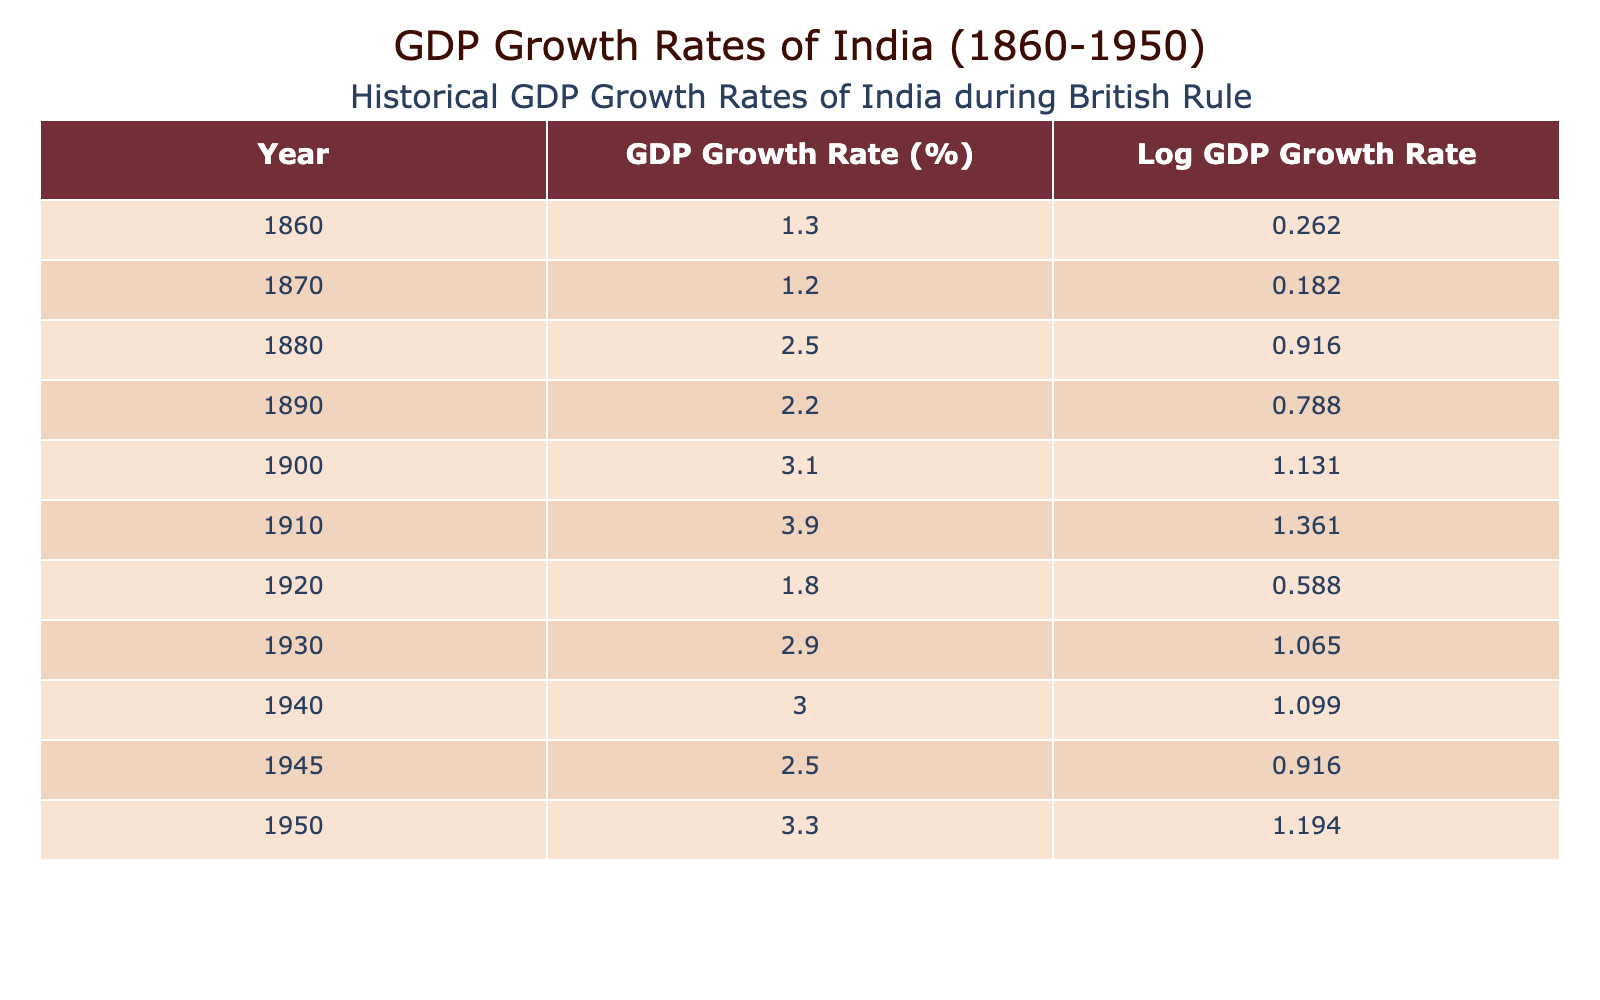What was the GDP growth rate in 1900? Referring to the table, the GDP growth rate for the year 1900 is listed as 3.1%.
Answer: 3.1% In which year did India experience the highest GDP growth rate? By examining the table, the highest GDP growth rate is 3.9%, which occurred in the year 1910.
Answer: 1910 What is the average GDP growth rate from 1860 to 1950? To calculate the average, sum the GDP growth rates from the table: (1.3 + 1.2 + 2.5 + 2.2 + 3.1 + 3.9 + 1.8 + 2.9 + 3.0 + 2.5 + 3.3) = 23.1. There are 11 data points, so the average is 23.1/11 = approximately 2.1%.
Answer: 2.1% Was the GDP growth rate higher in the 1940s than in the 1930s? The GDP growth rate for the 1930s is 2.9% (1930) and 3.0% (1940) while in 1945 it is 2.5%. The average for the 1940s is (3.0 + 2.5)/2 = 2.75%, which is lower than the average for the 1930s (2.9%). Thus, it is false.
Answer: No What is the difference in GDP growth rate between years 1880 and 1945? The GDP growth rate in 1880 is 2.5% and in 1945 it is 2.5%. Therefore, the difference is 2.5% - 2.5% = 0%.
Answer: 0% How many times did India achieve a GDP growth rate of over 3% during this period? By checking the table, the years 1900, 1910, 1940, and 1950 have GDP growth rates over 3%. This counts as four instances.
Answer: 4 In which decade did the GDP growth rate show a decrease from the previous decade? From the table, the GDP growth rate increased from the 1860s (1.3%) to the 1870s (1.2%) and remained more variable in the following decades. The rate decreased from 1920 (1.8%) to 1930 (2.9%). It then decreased again from 1940 (3.0%) to 1945 (2.5%).
Answer: 1940s Is it true that the GDP growth rate remained above 2% throughout the entire period? Checking the table reveals that the GDP growth rate fell below 2% in the years: 1860 (1.3%), 1870 (1.2%), and 1920 (1.8%). Hence, this statement is false.
Answer: No 